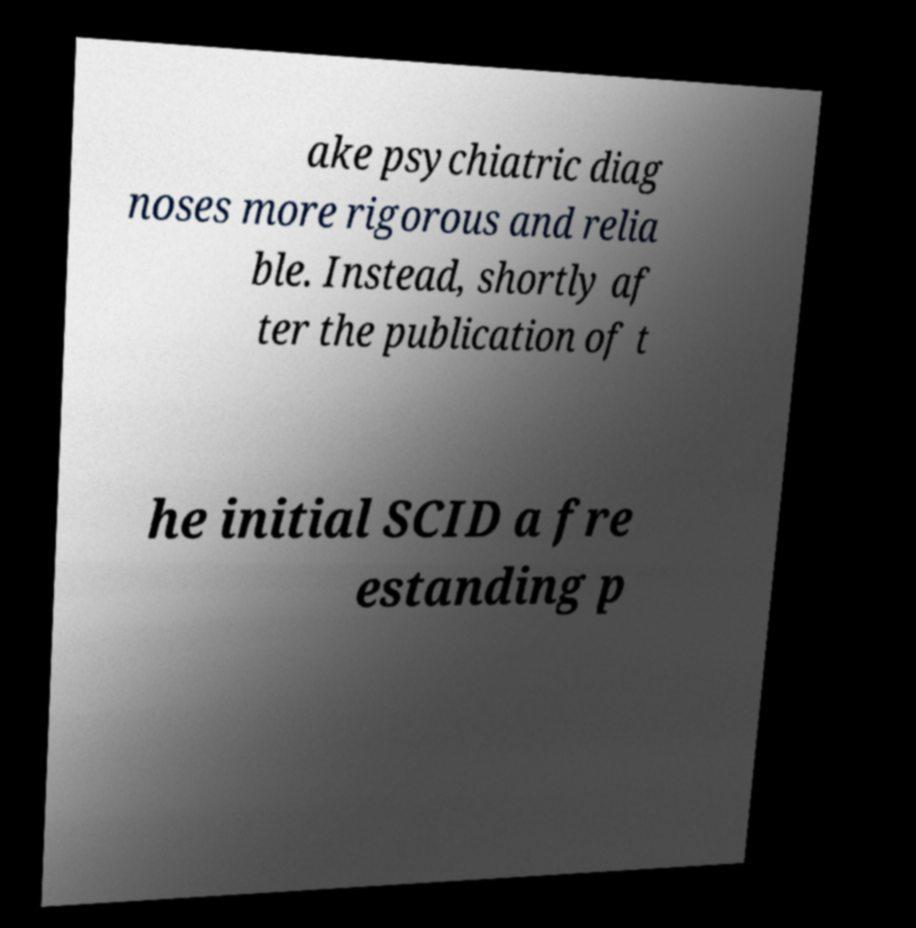Could you assist in decoding the text presented in this image and type it out clearly? ake psychiatric diag noses more rigorous and relia ble. Instead, shortly af ter the publication of t he initial SCID a fre estanding p 